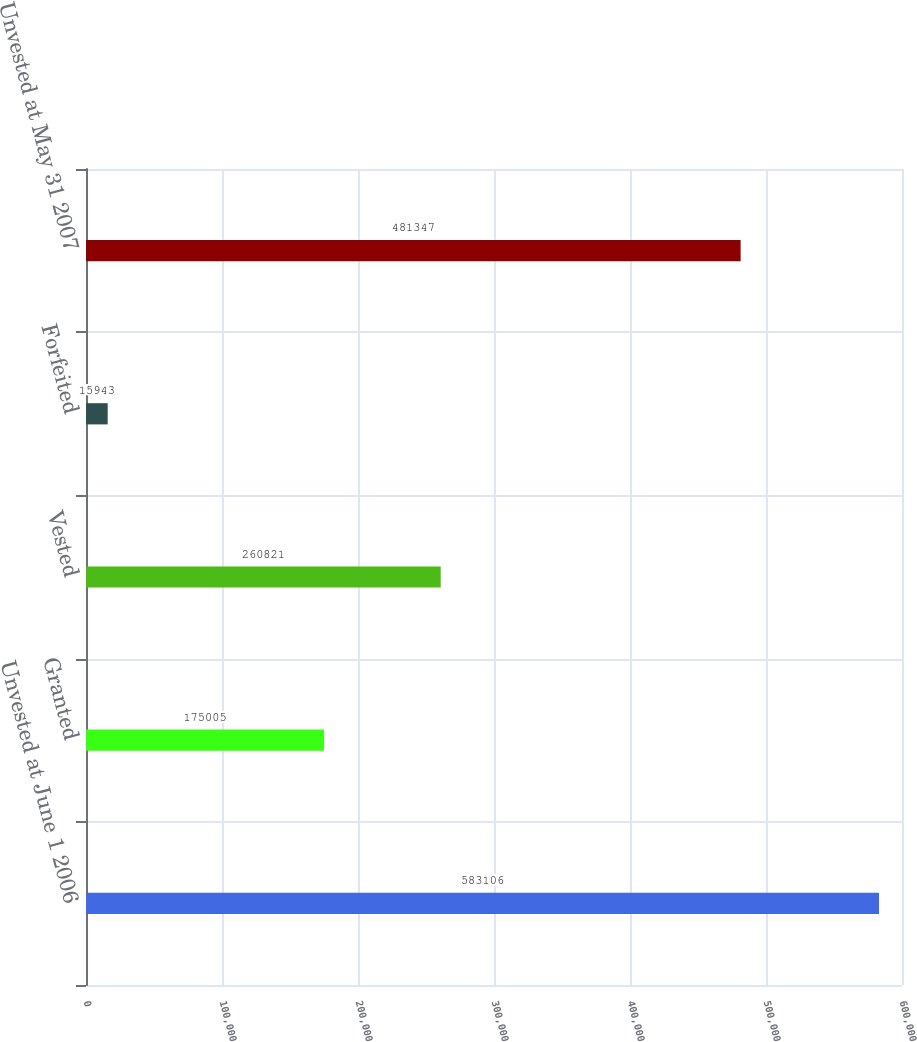Convert chart. <chart><loc_0><loc_0><loc_500><loc_500><bar_chart><fcel>Unvested at June 1 2006<fcel>Granted<fcel>Vested<fcel>Forfeited<fcel>Unvested at May 31 2007<nl><fcel>583106<fcel>175005<fcel>260821<fcel>15943<fcel>481347<nl></chart> 